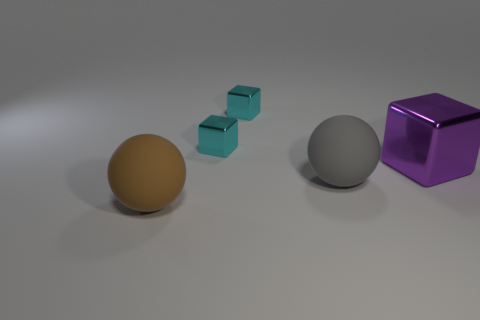What is the material of the purple object that is the same size as the brown matte object?
Provide a short and direct response. Metal. Are there any tiny objects that are right of the big ball behind the big brown ball?
Offer a terse response. No. There is a big thing on the left side of the large gray thing; is its shape the same as the large purple thing that is behind the brown rubber object?
Offer a very short reply. No. Do the big sphere right of the brown rubber ball and the large thing behind the gray rubber ball have the same material?
Offer a terse response. No. What is the material of the large purple object that is right of the big ball that is behind the brown ball?
Your answer should be very brief. Metal. There is a matte object that is on the right side of the big matte ball that is in front of the ball that is behind the big brown thing; what shape is it?
Your answer should be very brief. Sphere. What number of small gray metallic spheres are there?
Keep it short and to the point. 0. There is a object in front of the big gray matte object; what shape is it?
Ensure brevity in your answer.  Sphere. There is a metal block on the right side of the large matte thing to the right of the rubber object that is in front of the gray thing; what color is it?
Offer a very short reply. Purple. The big brown object that is the same material as the big gray thing is what shape?
Provide a short and direct response. Sphere. 